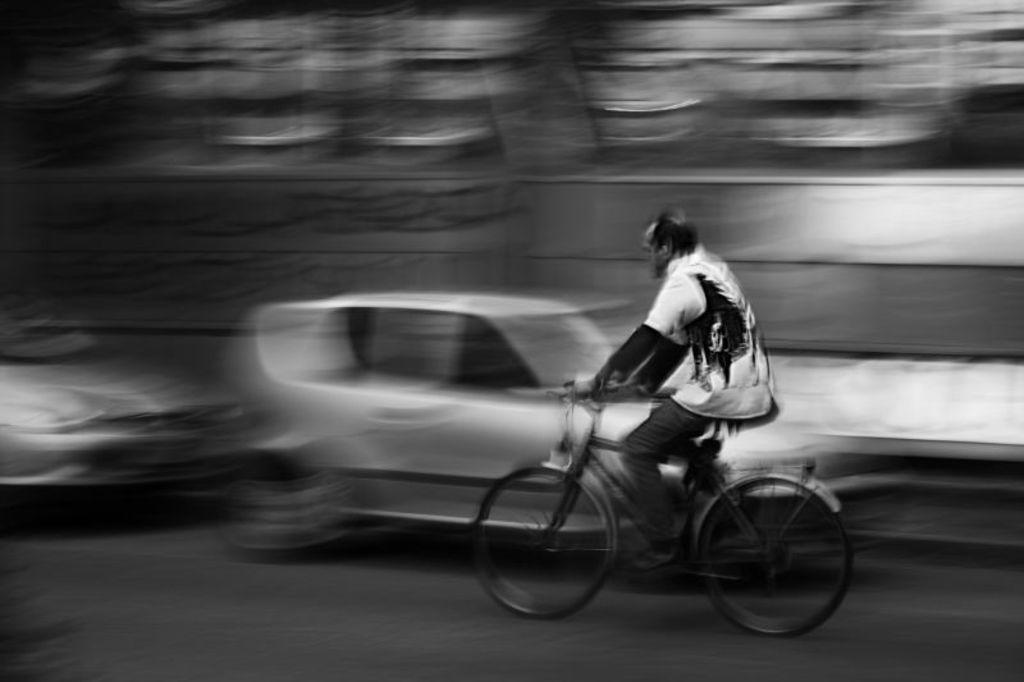What is the color scheme of the image? The image is black and white. What is the man in the image doing? The man is riding a bicycle in the image. Where is the man riding the bicycle? The man is riding the bicycle on a road. What else can be seen on the road in the image? There are vehicles parked on the road. How would you describe the background of the image? The background of the image is blurred. Are there any bears in the image that the man is afraid of? There are no bears present in the image, and the man does not appear to be afraid of anything. Can you tell me how many people are offering help to the man in the image? There are no people offering help to the man in the image, as he is riding a bicycle alone. 